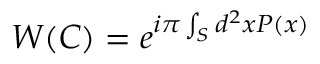<formula> <loc_0><loc_0><loc_500><loc_500>W ( C ) = e ^ { i \pi \int _ { S } d ^ { 2 } x P ( x ) }</formula> 